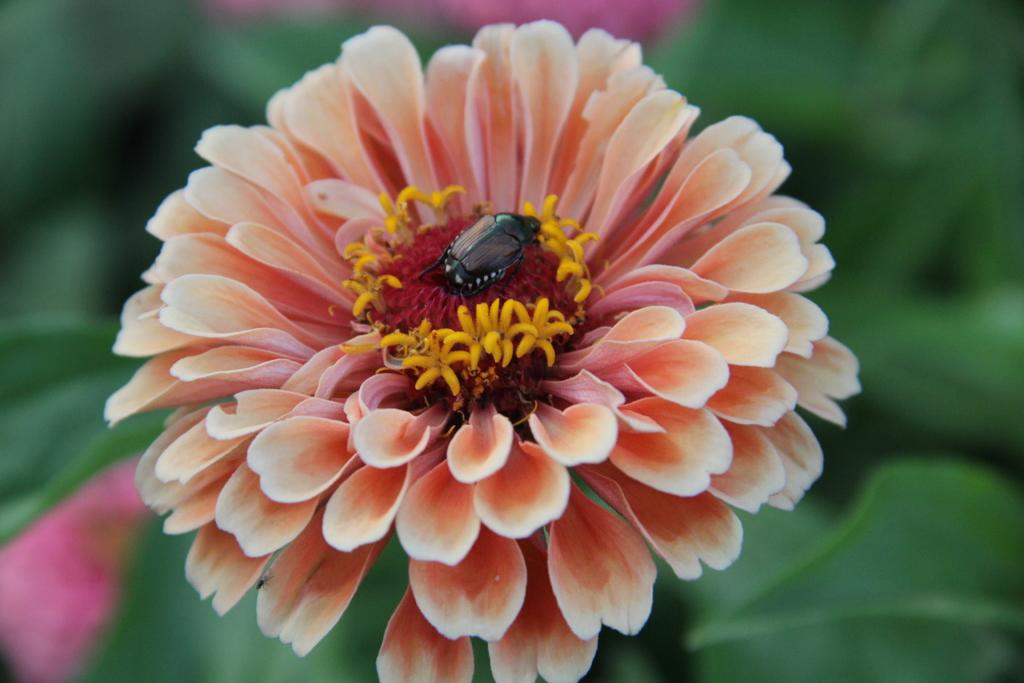What is the main subject of the image? There is a flower in the image. Is there anything else present on the flower? Yes, there is a small insect on the flower. What color is the background of the flower? The background of the flower is blue. What brand of toothpaste is being advertised on the flower in the image? There is no toothpaste or advertisement present in the image; it features a flower with a small insect on it. 